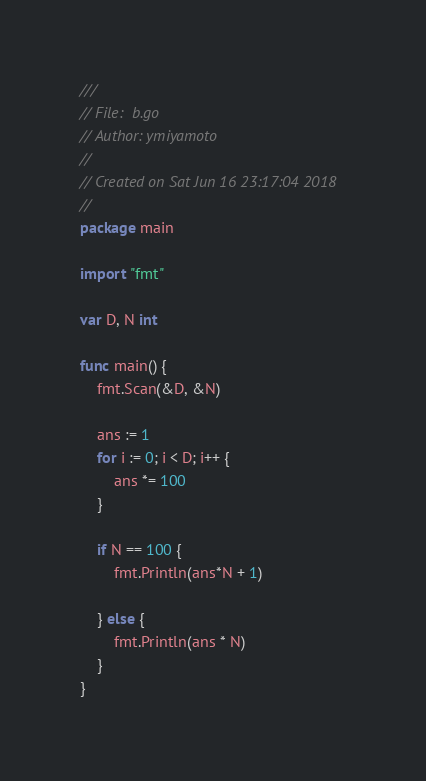Convert code to text. <code><loc_0><loc_0><loc_500><loc_500><_Go_>///
// File:  b.go
// Author: ymiyamoto
//
// Created on Sat Jun 16 23:17:04 2018
//
package main

import "fmt"

var D, N int

func main() {
	fmt.Scan(&D, &N)

	ans := 1
	for i := 0; i < D; i++ {
		ans *= 100
	}

	if N == 100 {
		fmt.Println(ans*N + 1)

	} else {
		fmt.Println(ans * N)
	}
}
</code> 